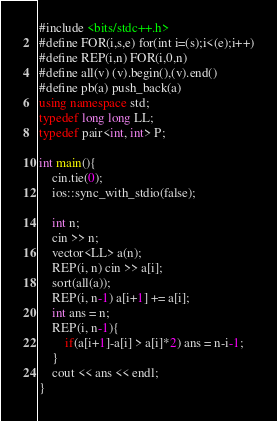<code> <loc_0><loc_0><loc_500><loc_500><_C++_>#include <bits/stdc++.h>
#define FOR(i,s,e) for(int i=(s);i<(e);i++)
#define REP(i,n) FOR(i,0,n)
#define all(v) (v).begin(),(v).end()
#define pb(a) push_back(a)
using namespace std;
typedef long long LL;
typedef pair<int, int> P;

int main(){
    cin.tie(0);
    ios::sync_with_stdio(false);

    int n;
    cin >> n;
    vector<LL> a(n);
    REP(i, n) cin >> a[i];
    sort(all(a));
    REP(i, n-1) a[i+1] += a[i];
    int ans = n;
    REP(i, n-1){
        if(a[i+1]-a[i] > a[i]*2) ans = n-i-1;
    }
    cout << ans << endl;
}
</code> 